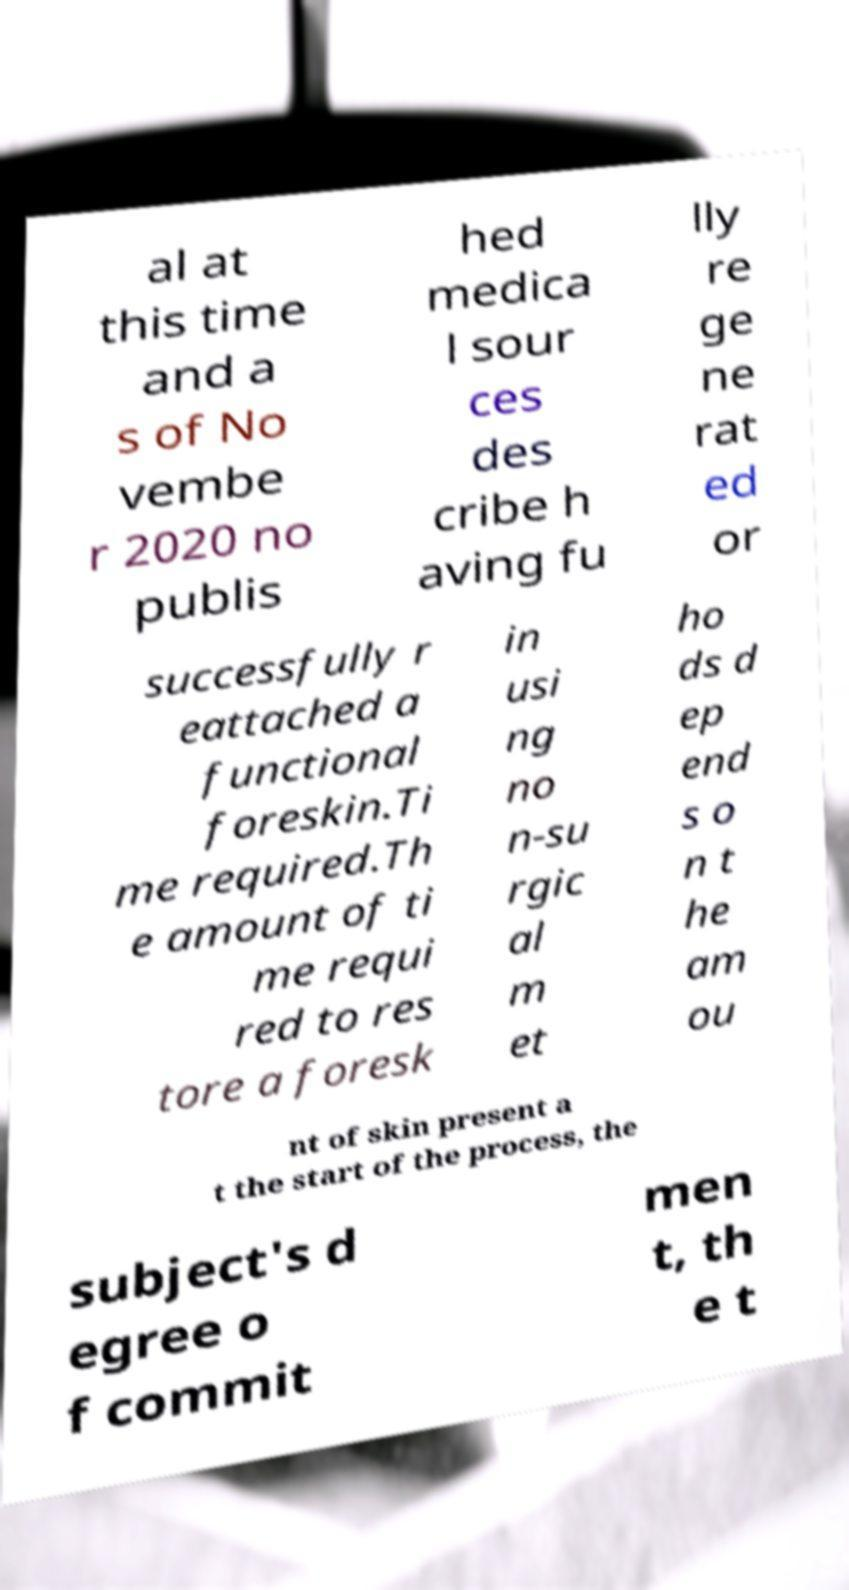There's text embedded in this image that I need extracted. Can you transcribe it verbatim? al at this time and a s of No vembe r 2020 no publis hed medica l sour ces des cribe h aving fu lly re ge ne rat ed or successfully r eattached a functional foreskin.Ti me required.Th e amount of ti me requi red to res tore a foresk in usi ng no n-su rgic al m et ho ds d ep end s o n t he am ou nt of skin present a t the start of the process, the subject's d egree o f commit men t, th e t 